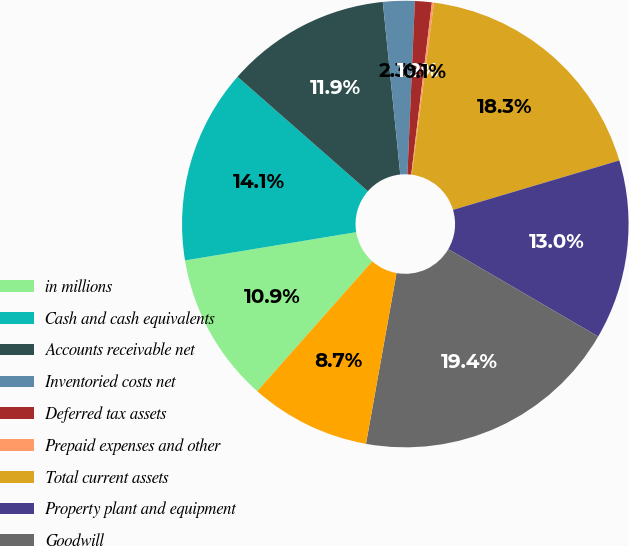Convert chart. <chart><loc_0><loc_0><loc_500><loc_500><pie_chart><fcel>in millions<fcel>Cash and cash equivalents<fcel>Accounts receivable net<fcel>Inventoried costs net<fcel>Deferred tax assets<fcel>Prepaid expenses and other<fcel>Total current assets<fcel>Property plant and equipment<fcel>Goodwill<fcel>Non-current deferred tax<nl><fcel>10.86%<fcel>14.07%<fcel>11.93%<fcel>2.29%<fcel>1.22%<fcel>0.15%<fcel>18.35%<fcel>13.0%<fcel>19.42%<fcel>8.72%<nl></chart> 